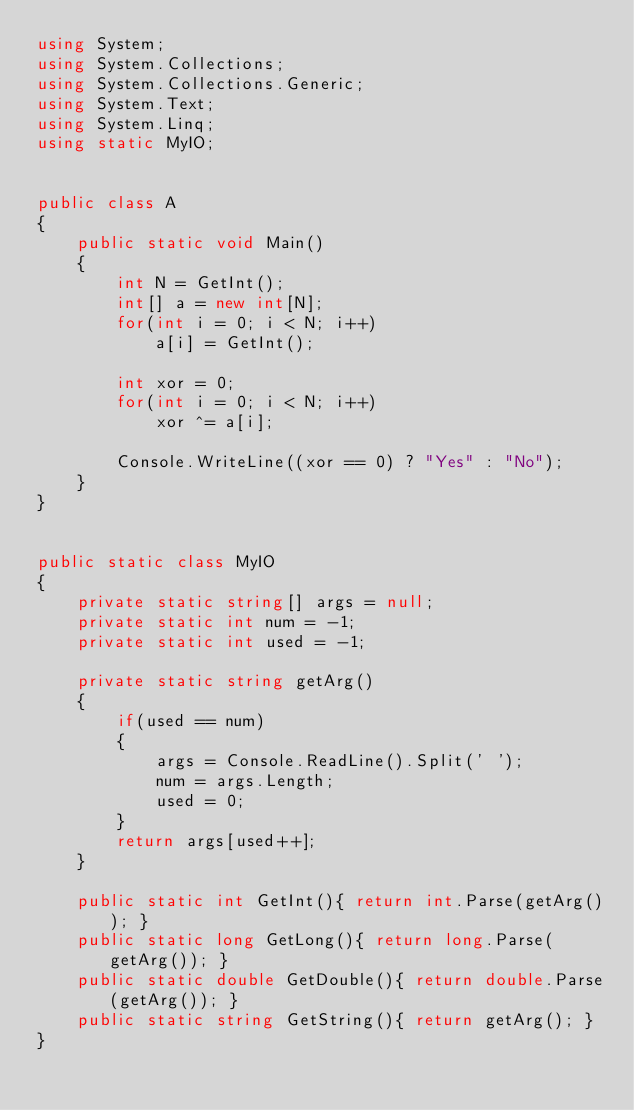Convert code to text. <code><loc_0><loc_0><loc_500><loc_500><_C#_>using System;
using System.Collections;
using System.Collections.Generic;
using System.Text;
using System.Linq;
using static MyIO;


public class A
{
	public static void Main()
	{
		int N = GetInt();
		int[] a = new int[N];
		for(int i = 0; i < N; i++)
			a[i] = GetInt();

		int xor = 0;
		for(int i = 0; i < N; i++)
			xor ^= a[i];
	
		Console.WriteLine((xor == 0) ? "Yes" : "No");
	}
}


public static class MyIO
{
	private static string[] args = null;
	private static int num = -1;
	private static int used = -1;

	private static string getArg()
	{
		if(used == num)
		{
			args = Console.ReadLine().Split(' ');
			num = args.Length;
			used = 0;
		}
		return args[used++];
	}

	public static int GetInt(){ return int.Parse(getArg()); }
	public static long GetLong(){ return long.Parse(getArg()); }
	public static double GetDouble(){ return double.Parse(getArg()); }
	public static string GetString(){ return getArg(); }
}</code> 